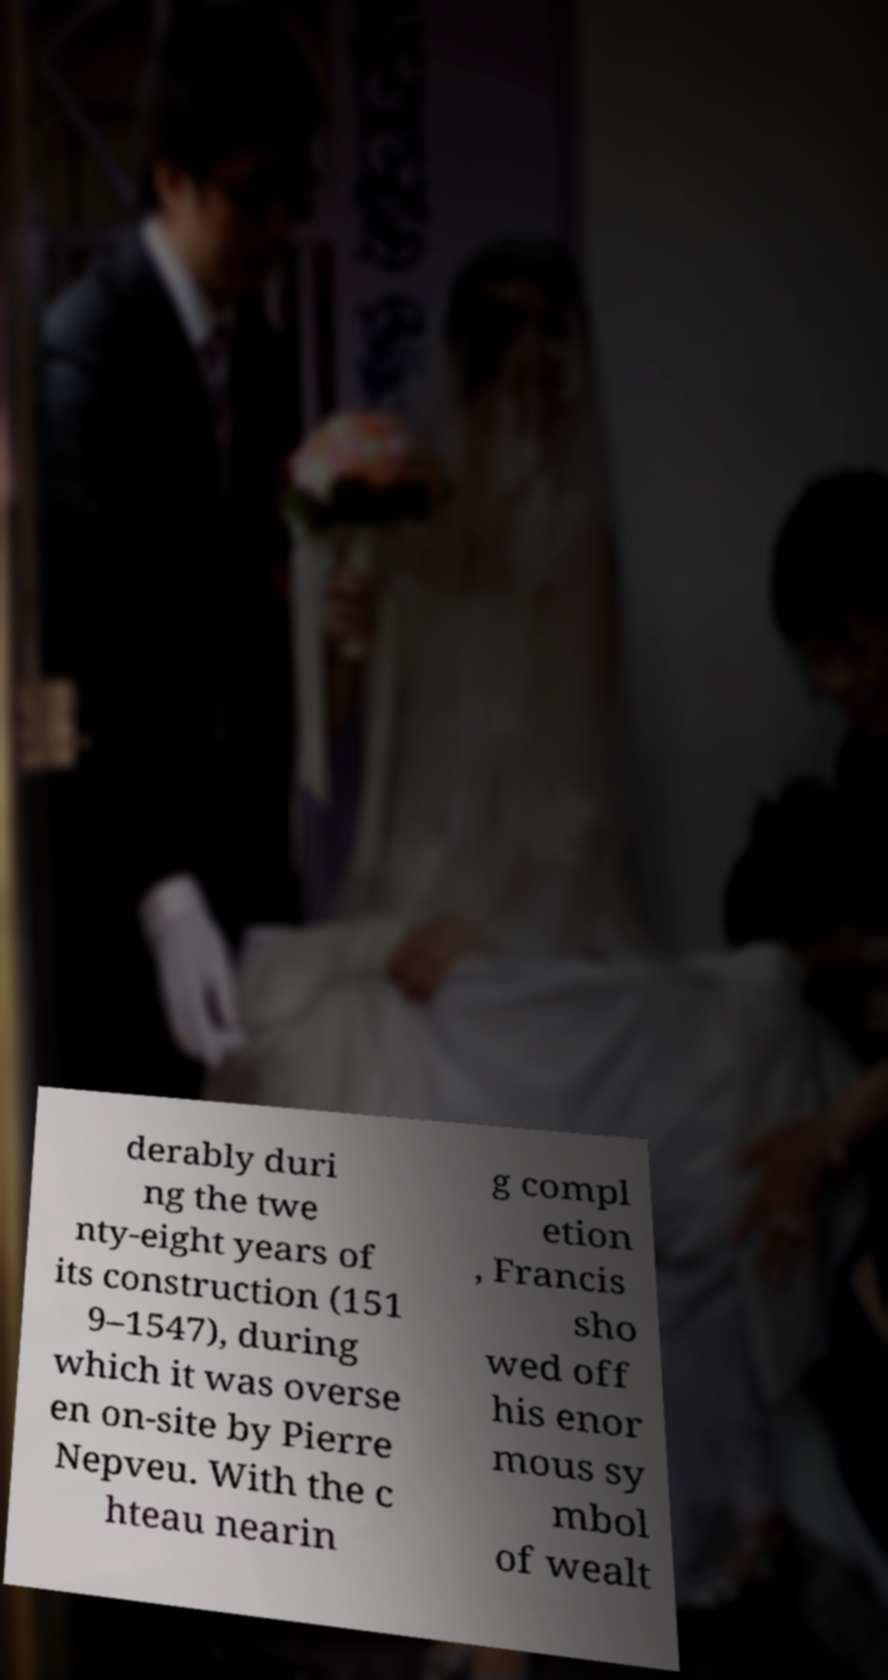Can you accurately transcribe the text from the provided image for me? derably duri ng the twe nty-eight years of its construction (151 9–1547), during which it was overse en on-site by Pierre Nepveu. With the c hteau nearin g compl etion , Francis sho wed off his enor mous sy mbol of wealt 